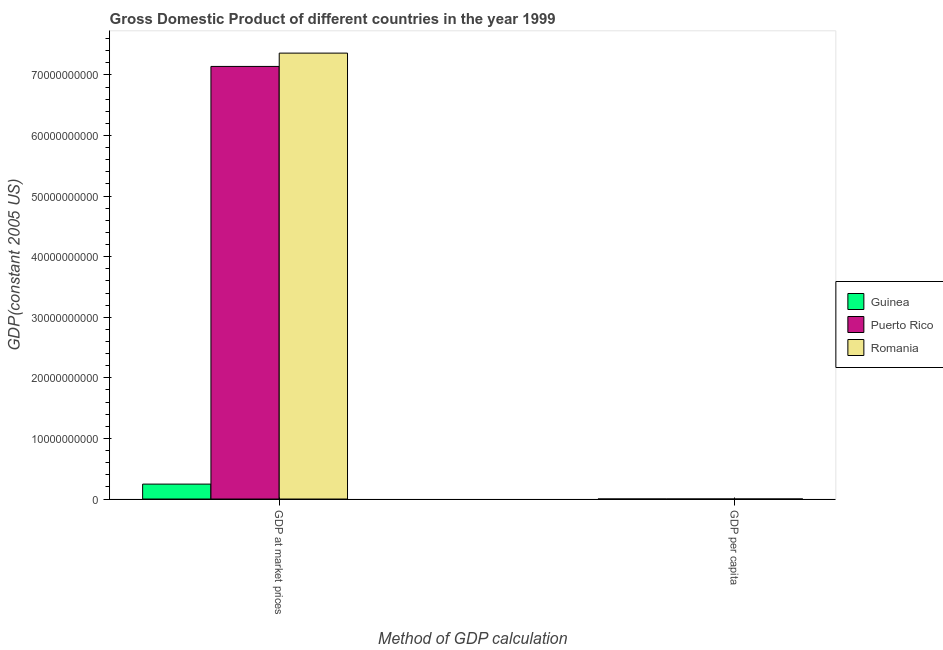How many groups of bars are there?
Offer a terse response. 2. How many bars are there on the 2nd tick from the left?
Your answer should be compact. 3. How many bars are there on the 1st tick from the right?
Make the answer very short. 3. What is the label of the 2nd group of bars from the left?
Your answer should be very brief. GDP per capita. What is the gdp per capita in Puerto Rico?
Offer a terse response. 1.88e+04. Across all countries, what is the maximum gdp per capita?
Provide a succinct answer. 1.88e+04. Across all countries, what is the minimum gdp per capita?
Offer a terse response. 284.81. In which country was the gdp at market prices maximum?
Provide a short and direct response. Romania. In which country was the gdp at market prices minimum?
Ensure brevity in your answer.  Guinea. What is the total gdp per capita in the graph?
Offer a terse response. 2.23e+04. What is the difference between the gdp per capita in Guinea and that in Puerto Rico?
Make the answer very short. -1.85e+04. What is the difference between the gdp at market prices in Guinea and the gdp per capita in Romania?
Keep it short and to the point. 2.46e+09. What is the average gdp per capita per country?
Your answer should be very brief. 7449.56. What is the difference between the gdp at market prices and gdp per capita in Guinea?
Offer a terse response. 2.46e+09. What is the ratio of the gdp per capita in Romania to that in Puerto Rico?
Your answer should be very brief. 0.17. Is the gdp per capita in Puerto Rico less than that in Guinea?
Offer a terse response. No. What does the 2nd bar from the left in GDP at market prices represents?
Your answer should be compact. Puerto Rico. What does the 1st bar from the right in GDP at market prices represents?
Ensure brevity in your answer.  Romania. How many bars are there?
Your answer should be compact. 6. How many countries are there in the graph?
Your answer should be compact. 3. What is the difference between two consecutive major ticks on the Y-axis?
Offer a very short reply. 1.00e+1. Are the values on the major ticks of Y-axis written in scientific E-notation?
Provide a short and direct response. No. Does the graph contain any zero values?
Your answer should be compact. No. How many legend labels are there?
Offer a very short reply. 3. What is the title of the graph?
Your answer should be very brief. Gross Domestic Product of different countries in the year 1999. Does "Mauritania" appear as one of the legend labels in the graph?
Offer a terse response. No. What is the label or title of the X-axis?
Offer a terse response. Method of GDP calculation. What is the label or title of the Y-axis?
Your response must be concise. GDP(constant 2005 US). What is the GDP(constant 2005 US) in Guinea in GDP at market prices?
Make the answer very short. 2.46e+09. What is the GDP(constant 2005 US) in Puerto Rico in GDP at market prices?
Give a very brief answer. 7.14e+1. What is the GDP(constant 2005 US) of Romania in GDP at market prices?
Provide a short and direct response. 7.36e+1. What is the GDP(constant 2005 US) of Guinea in GDP per capita?
Your response must be concise. 284.81. What is the GDP(constant 2005 US) of Puerto Rico in GDP per capita?
Provide a succinct answer. 1.88e+04. What is the GDP(constant 2005 US) in Romania in GDP per capita?
Ensure brevity in your answer.  3275.03. Across all Method of GDP calculation, what is the maximum GDP(constant 2005 US) in Guinea?
Offer a terse response. 2.46e+09. Across all Method of GDP calculation, what is the maximum GDP(constant 2005 US) in Puerto Rico?
Offer a very short reply. 7.14e+1. Across all Method of GDP calculation, what is the maximum GDP(constant 2005 US) in Romania?
Offer a terse response. 7.36e+1. Across all Method of GDP calculation, what is the minimum GDP(constant 2005 US) in Guinea?
Give a very brief answer. 284.81. Across all Method of GDP calculation, what is the minimum GDP(constant 2005 US) of Puerto Rico?
Provide a succinct answer. 1.88e+04. Across all Method of GDP calculation, what is the minimum GDP(constant 2005 US) of Romania?
Provide a short and direct response. 3275.03. What is the total GDP(constant 2005 US) in Guinea in the graph?
Your answer should be compact. 2.46e+09. What is the total GDP(constant 2005 US) of Puerto Rico in the graph?
Your answer should be very brief. 7.14e+1. What is the total GDP(constant 2005 US) of Romania in the graph?
Provide a succinct answer. 7.36e+1. What is the difference between the GDP(constant 2005 US) of Guinea in GDP at market prices and that in GDP per capita?
Ensure brevity in your answer.  2.46e+09. What is the difference between the GDP(constant 2005 US) of Puerto Rico in GDP at market prices and that in GDP per capita?
Ensure brevity in your answer.  7.14e+1. What is the difference between the GDP(constant 2005 US) of Romania in GDP at market prices and that in GDP per capita?
Keep it short and to the point. 7.36e+1. What is the difference between the GDP(constant 2005 US) in Guinea in GDP at market prices and the GDP(constant 2005 US) in Puerto Rico in GDP per capita?
Make the answer very short. 2.46e+09. What is the difference between the GDP(constant 2005 US) of Guinea in GDP at market prices and the GDP(constant 2005 US) of Romania in GDP per capita?
Your answer should be compact. 2.46e+09. What is the difference between the GDP(constant 2005 US) in Puerto Rico in GDP at market prices and the GDP(constant 2005 US) in Romania in GDP per capita?
Make the answer very short. 7.14e+1. What is the average GDP(constant 2005 US) in Guinea per Method of GDP calculation?
Provide a succinct answer. 1.23e+09. What is the average GDP(constant 2005 US) of Puerto Rico per Method of GDP calculation?
Your response must be concise. 3.57e+1. What is the average GDP(constant 2005 US) of Romania per Method of GDP calculation?
Ensure brevity in your answer.  3.68e+1. What is the difference between the GDP(constant 2005 US) in Guinea and GDP(constant 2005 US) in Puerto Rico in GDP at market prices?
Provide a short and direct response. -6.89e+1. What is the difference between the GDP(constant 2005 US) in Guinea and GDP(constant 2005 US) in Romania in GDP at market prices?
Your answer should be very brief. -7.11e+1. What is the difference between the GDP(constant 2005 US) in Puerto Rico and GDP(constant 2005 US) in Romania in GDP at market prices?
Give a very brief answer. -2.20e+09. What is the difference between the GDP(constant 2005 US) of Guinea and GDP(constant 2005 US) of Puerto Rico in GDP per capita?
Offer a terse response. -1.85e+04. What is the difference between the GDP(constant 2005 US) in Guinea and GDP(constant 2005 US) in Romania in GDP per capita?
Your answer should be compact. -2990.21. What is the difference between the GDP(constant 2005 US) in Puerto Rico and GDP(constant 2005 US) in Romania in GDP per capita?
Keep it short and to the point. 1.55e+04. What is the ratio of the GDP(constant 2005 US) of Guinea in GDP at market prices to that in GDP per capita?
Ensure brevity in your answer.  8.65e+06. What is the ratio of the GDP(constant 2005 US) in Puerto Rico in GDP at market prices to that in GDP per capita?
Your answer should be compact. 3.80e+06. What is the ratio of the GDP(constant 2005 US) in Romania in GDP at market prices to that in GDP per capita?
Provide a succinct answer. 2.25e+07. What is the difference between the highest and the second highest GDP(constant 2005 US) in Guinea?
Keep it short and to the point. 2.46e+09. What is the difference between the highest and the second highest GDP(constant 2005 US) in Puerto Rico?
Offer a terse response. 7.14e+1. What is the difference between the highest and the second highest GDP(constant 2005 US) of Romania?
Your response must be concise. 7.36e+1. What is the difference between the highest and the lowest GDP(constant 2005 US) in Guinea?
Ensure brevity in your answer.  2.46e+09. What is the difference between the highest and the lowest GDP(constant 2005 US) of Puerto Rico?
Offer a terse response. 7.14e+1. What is the difference between the highest and the lowest GDP(constant 2005 US) of Romania?
Offer a terse response. 7.36e+1. 